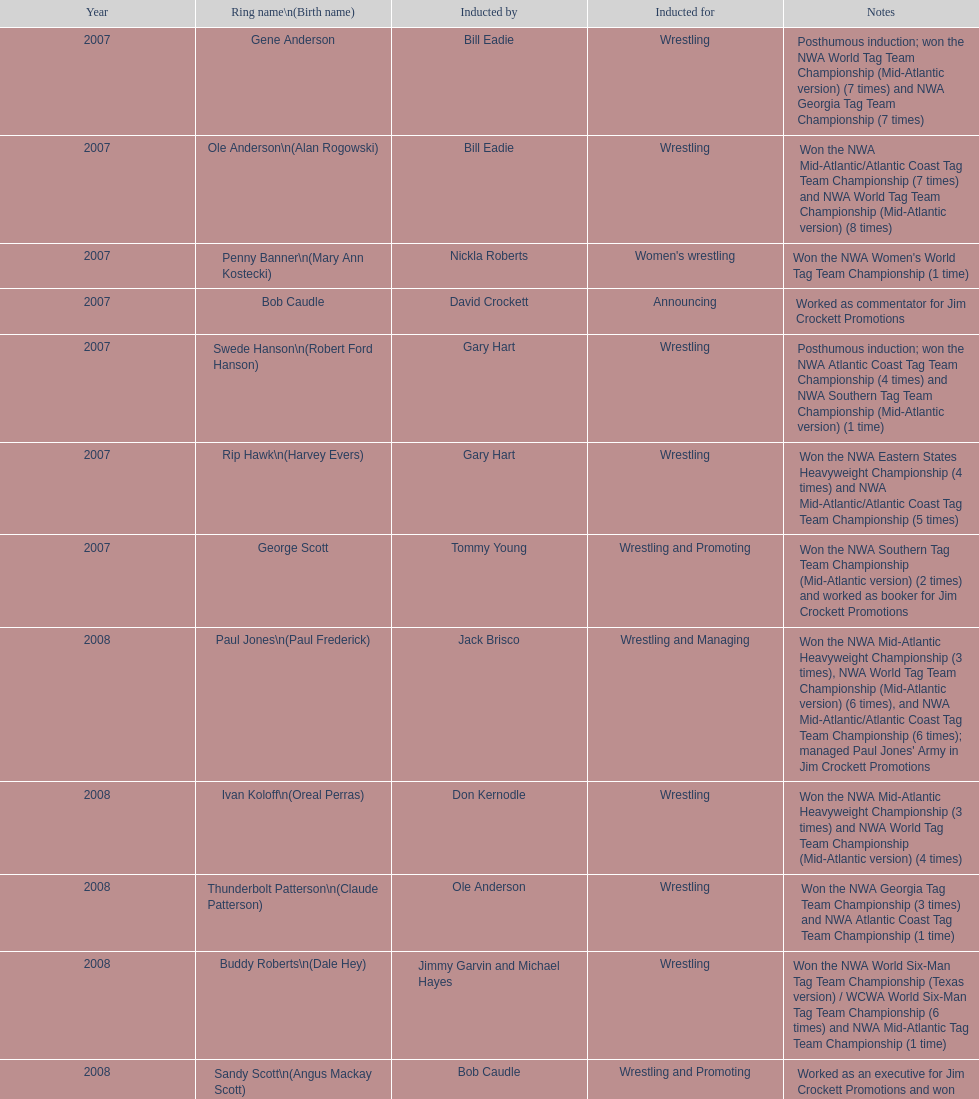How many members were inducted for announcing? 2. 